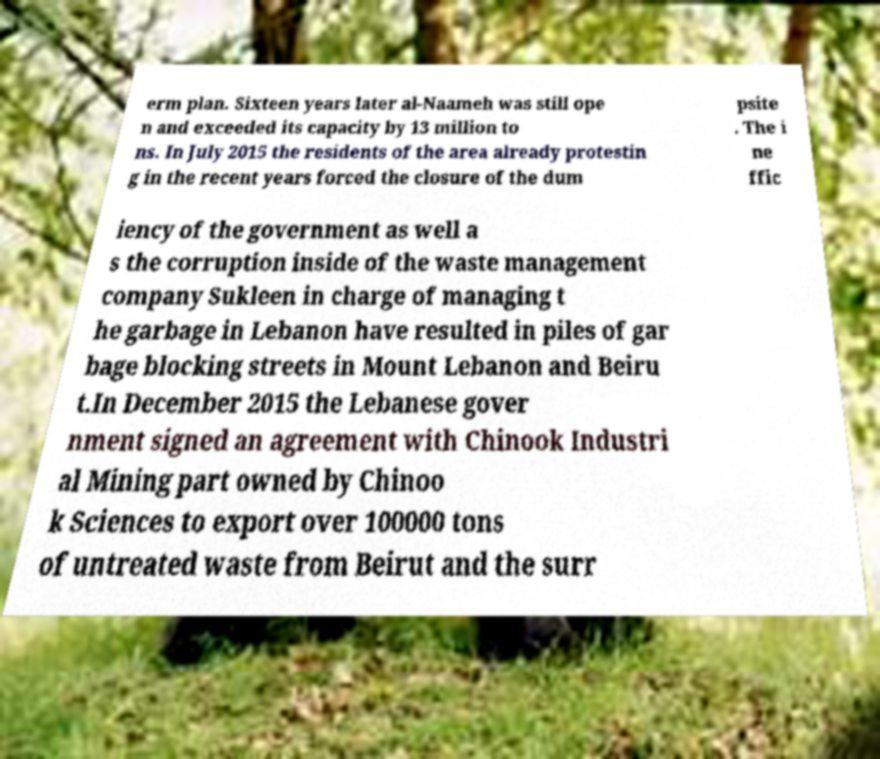Could you assist in decoding the text presented in this image and type it out clearly? erm plan. Sixteen years later al-Naameh was still ope n and exceeded its capacity by 13 million to ns. In July 2015 the residents of the area already protestin g in the recent years forced the closure of the dum psite . The i ne ffic iency of the government as well a s the corruption inside of the waste management company Sukleen in charge of managing t he garbage in Lebanon have resulted in piles of gar bage blocking streets in Mount Lebanon and Beiru t.In December 2015 the Lebanese gover nment signed an agreement with Chinook Industri al Mining part owned by Chinoo k Sciences to export over 100000 tons of untreated waste from Beirut and the surr 